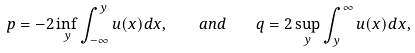<formula> <loc_0><loc_0><loc_500><loc_500>p = - 2 \inf _ { y } \int _ { - \infty } ^ { y } u ( x ) d x , \quad a n d \quad q = 2 \sup _ { y } \int _ { y } ^ { \infty } u ( x ) d x ,</formula> 